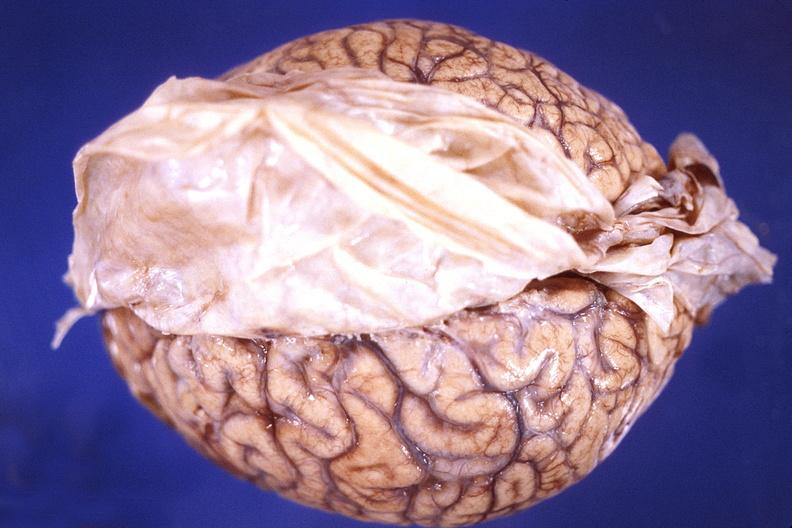what does this image show?
Answer the question using a single word or phrase. Brain 